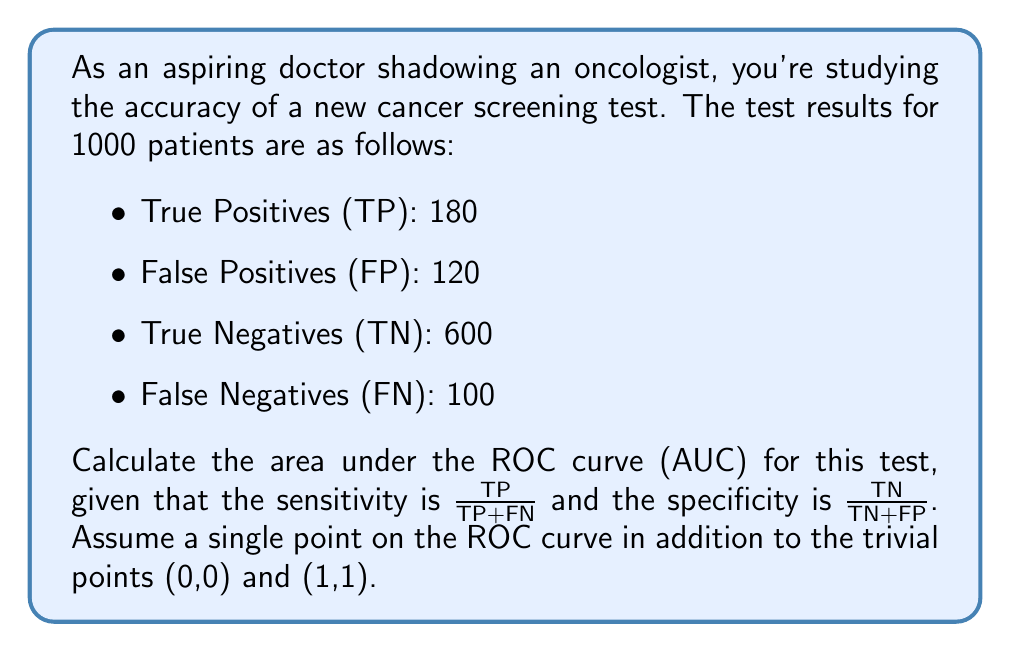Show me your answer to this math problem. To calculate the area under the ROC curve (AUC) for this cancer screening test, we'll follow these steps:

1) Calculate the sensitivity:
   $$\text{Sensitivity} = \frac{TP}{TP+FN} = \frac{180}{180+100} = \frac{180}{280} = 0.6429$$

2) Calculate the specificity:
   $$\text{Specificity} = \frac{TN}{TN+FP} = \frac{600}{600+120} = \frac{600}{720} = 0.8333$$

3) Calculate 1 - Specificity:
   $$1 - \text{Specificity} = 1 - 0.8333 = 0.1667$$

4) Now we have three points on the ROC curve:
   (0,0), (0.1667, 0.6429), and (1,1)

5) The AUC can be calculated by dividing the ROC space into trapezoids and summing their areas:

   Area of first trapezoid:
   $$A_1 = \frac{1}{2} (0.1667 - 0) (0.6429 + 0) = 0.0536$$

   Area of second trapezoid:
   $$A_2 = \frac{1}{2} (1 - 0.1667) (1 + 0.6429) = 0.6845$$

6) The total AUC is the sum of these areas:
   $$\text{AUC} = A_1 + A_2 = 0.0536 + 0.6845 = 0.7381$$

The AUC of 0.7381 indicates that the test has good discriminatory power, as it's significantly better than random guessing (AUC = 0.5) and approaching excellent accuracy (typically considered AUC > 0.8).
Answer: 0.7381 